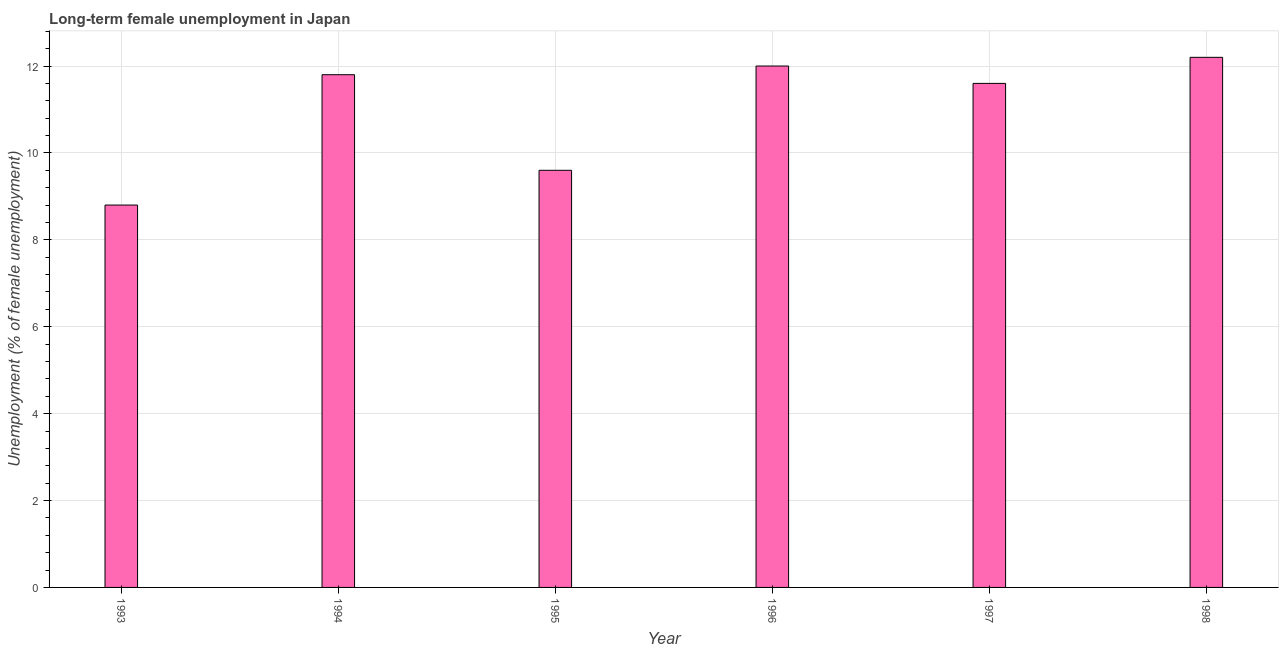Does the graph contain any zero values?
Provide a succinct answer. No. What is the title of the graph?
Provide a short and direct response. Long-term female unemployment in Japan. What is the label or title of the X-axis?
Give a very brief answer. Year. What is the label or title of the Y-axis?
Keep it short and to the point. Unemployment (% of female unemployment). What is the long-term female unemployment in 1993?
Offer a very short reply. 8.8. Across all years, what is the maximum long-term female unemployment?
Provide a succinct answer. 12.2. Across all years, what is the minimum long-term female unemployment?
Make the answer very short. 8.8. In which year was the long-term female unemployment minimum?
Your answer should be compact. 1993. What is the sum of the long-term female unemployment?
Your response must be concise. 66. What is the median long-term female unemployment?
Your response must be concise. 11.7. Do a majority of the years between 1995 and 1994 (inclusive) have long-term female unemployment greater than 4.8 %?
Provide a short and direct response. No. In how many years, is the long-term female unemployment greater than the average long-term female unemployment taken over all years?
Your response must be concise. 4. Are all the bars in the graph horizontal?
Provide a succinct answer. No. What is the difference between two consecutive major ticks on the Y-axis?
Keep it short and to the point. 2. What is the Unemployment (% of female unemployment) of 1993?
Your answer should be very brief. 8.8. What is the Unemployment (% of female unemployment) of 1994?
Provide a succinct answer. 11.8. What is the Unemployment (% of female unemployment) of 1995?
Make the answer very short. 9.6. What is the Unemployment (% of female unemployment) of 1996?
Offer a terse response. 12. What is the Unemployment (% of female unemployment) in 1997?
Make the answer very short. 11.6. What is the Unemployment (% of female unemployment) in 1998?
Make the answer very short. 12.2. What is the difference between the Unemployment (% of female unemployment) in 1993 and 1994?
Ensure brevity in your answer.  -3. What is the difference between the Unemployment (% of female unemployment) in 1993 and 1995?
Your answer should be very brief. -0.8. What is the difference between the Unemployment (% of female unemployment) in 1993 and 1996?
Provide a succinct answer. -3.2. What is the difference between the Unemployment (% of female unemployment) in 1993 and 1997?
Provide a short and direct response. -2.8. What is the difference between the Unemployment (% of female unemployment) in 1993 and 1998?
Offer a very short reply. -3.4. What is the difference between the Unemployment (% of female unemployment) in 1994 and 1995?
Provide a short and direct response. 2.2. What is the difference between the Unemployment (% of female unemployment) in 1994 and 1997?
Provide a short and direct response. 0.2. What is the difference between the Unemployment (% of female unemployment) in 1994 and 1998?
Ensure brevity in your answer.  -0.4. What is the difference between the Unemployment (% of female unemployment) in 1995 and 1996?
Give a very brief answer. -2.4. What is the difference between the Unemployment (% of female unemployment) in 1995 and 1998?
Ensure brevity in your answer.  -2.6. What is the difference between the Unemployment (% of female unemployment) in 1996 and 1998?
Ensure brevity in your answer.  -0.2. What is the difference between the Unemployment (% of female unemployment) in 1997 and 1998?
Provide a short and direct response. -0.6. What is the ratio of the Unemployment (% of female unemployment) in 1993 to that in 1994?
Provide a succinct answer. 0.75. What is the ratio of the Unemployment (% of female unemployment) in 1993 to that in 1995?
Ensure brevity in your answer.  0.92. What is the ratio of the Unemployment (% of female unemployment) in 1993 to that in 1996?
Ensure brevity in your answer.  0.73. What is the ratio of the Unemployment (% of female unemployment) in 1993 to that in 1997?
Offer a very short reply. 0.76. What is the ratio of the Unemployment (% of female unemployment) in 1993 to that in 1998?
Your response must be concise. 0.72. What is the ratio of the Unemployment (% of female unemployment) in 1994 to that in 1995?
Provide a short and direct response. 1.23. What is the ratio of the Unemployment (% of female unemployment) in 1994 to that in 1996?
Your answer should be compact. 0.98. What is the ratio of the Unemployment (% of female unemployment) in 1994 to that in 1997?
Your response must be concise. 1.02. What is the ratio of the Unemployment (% of female unemployment) in 1995 to that in 1997?
Make the answer very short. 0.83. What is the ratio of the Unemployment (% of female unemployment) in 1995 to that in 1998?
Provide a succinct answer. 0.79. What is the ratio of the Unemployment (% of female unemployment) in 1996 to that in 1997?
Make the answer very short. 1.03. What is the ratio of the Unemployment (% of female unemployment) in 1997 to that in 1998?
Your response must be concise. 0.95. 